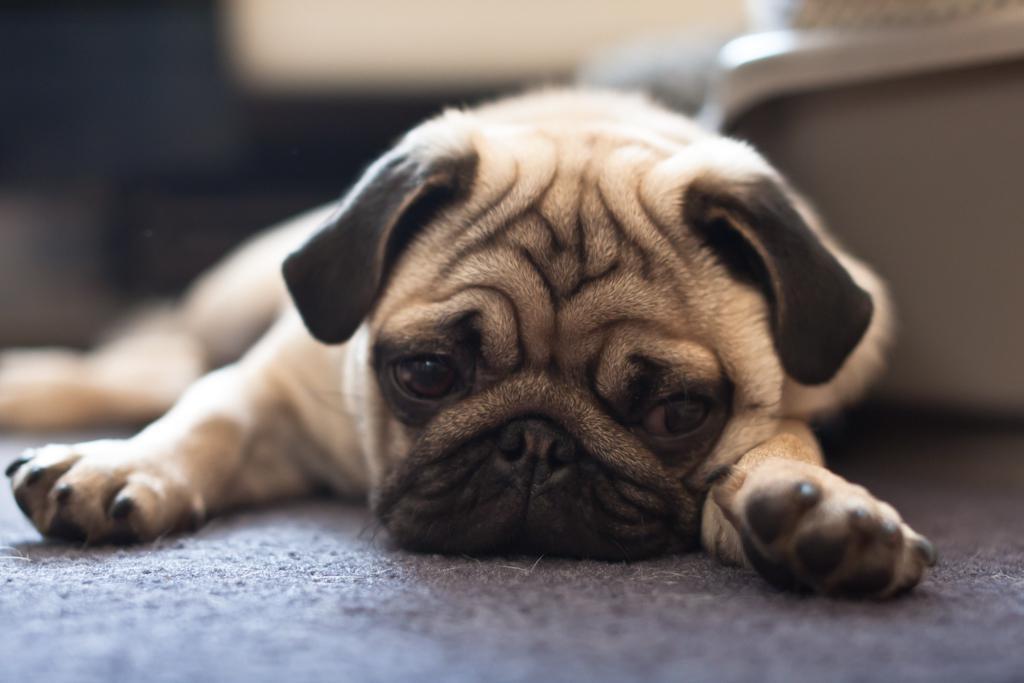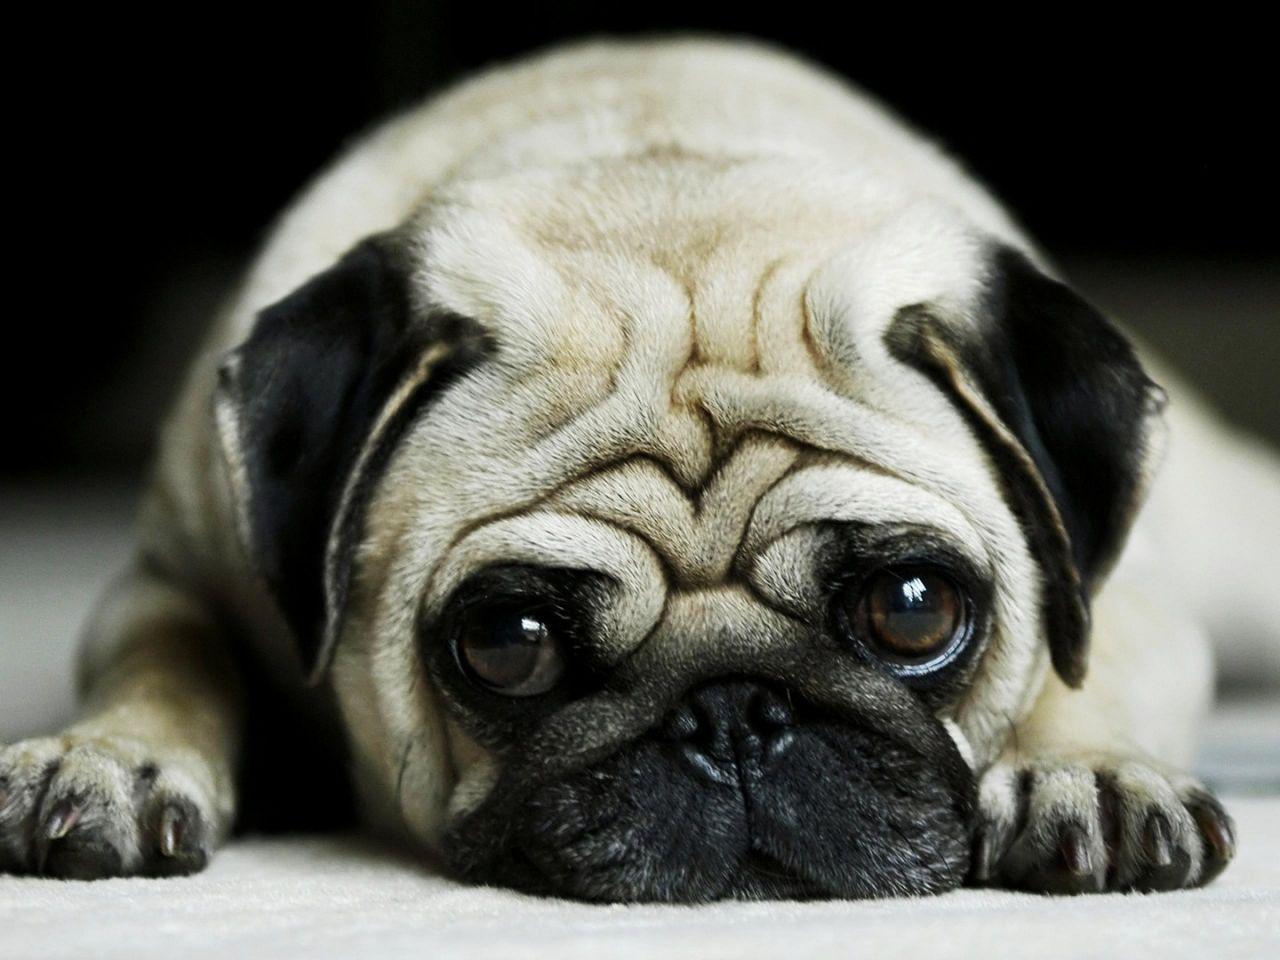The first image is the image on the left, the second image is the image on the right. Examine the images to the left and right. Is the description "The pug reclining in the right image has paws extended in front." accurate? Answer yes or no. Yes. 